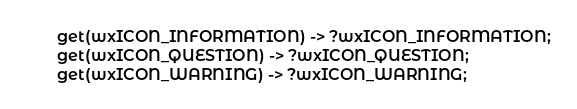Convert code to text. <code><loc_0><loc_0><loc_500><loc_500><_Erlang_>  get(wxICON_INFORMATION) -> ?wxICON_INFORMATION;
  get(wxICON_QUESTION) -> ?wxICON_QUESTION;
  get(wxICON_WARNING) -> ?wxICON_WARNING;</code> 